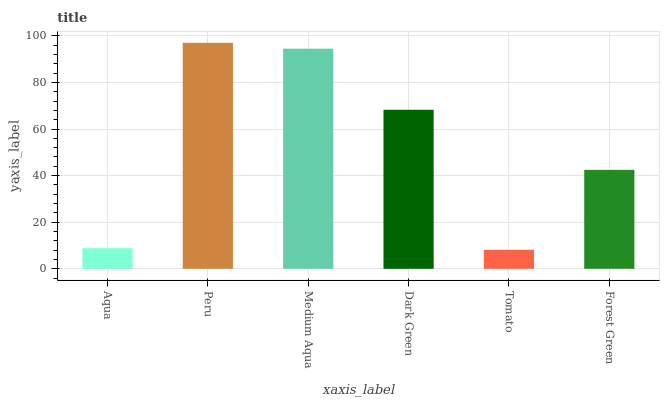Is Tomato the minimum?
Answer yes or no. Yes. Is Peru the maximum?
Answer yes or no. Yes. Is Medium Aqua the minimum?
Answer yes or no. No. Is Medium Aqua the maximum?
Answer yes or no. No. Is Peru greater than Medium Aqua?
Answer yes or no. Yes. Is Medium Aqua less than Peru?
Answer yes or no. Yes. Is Medium Aqua greater than Peru?
Answer yes or no. No. Is Peru less than Medium Aqua?
Answer yes or no. No. Is Dark Green the high median?
Answer yes or no. Yes. Is Forest Green the low median?
Answer yes or no. Yes. Is Forest Green the high median?
Answer yes or no. No. Is Aqua the low median?
Answer yes or no. No. 